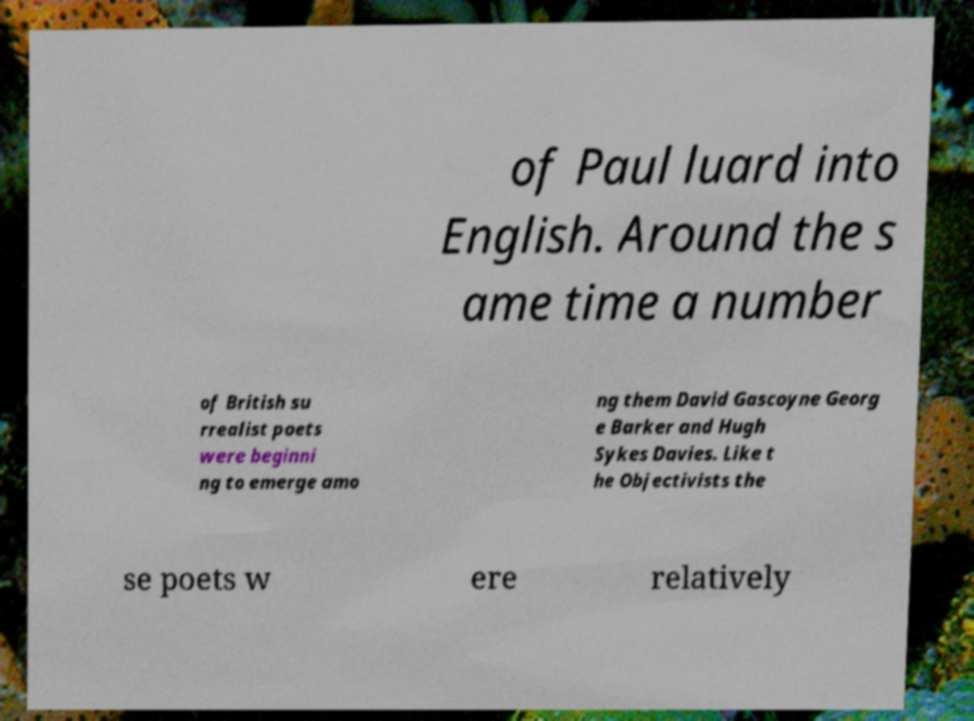Could you extract and type out the text from this image? of Paul luard into English. Around the s ame time a number of British su rrealist poets were beginni ng to emerge amo ng them David Gascoyne Georg e Barker and Hugh Sykes Davies. Like t he Objectivists the se poets w ere relatively 